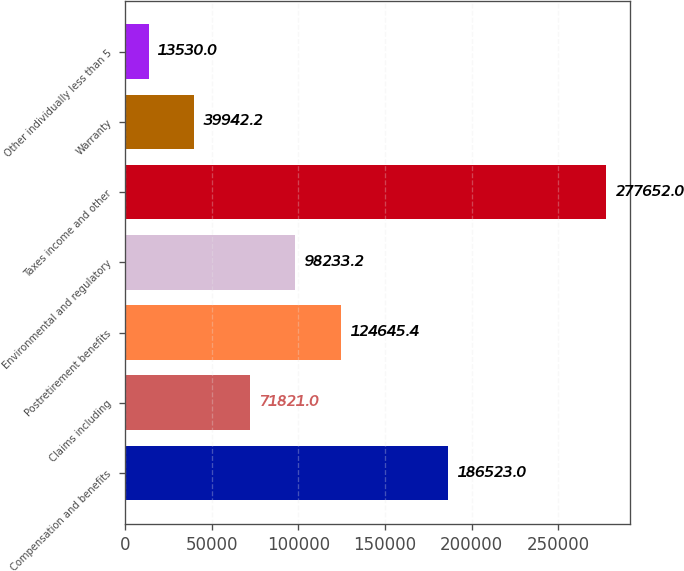Convert chart. <chart><loc_0><loc_0><loc_500><loc_500><bar_chart><fcel>Compensation and benefits<fcel>Claims including<fcel>Postretirement benefits<fcel>Environmental and regulatory<fcel>Taxes income and other<fcel>Warranty<fcel>Other individually less than 5<nl><fcel>186523<fcel>71821<fcel>124645<fcel>98233.2<fcel>277652<fcel>39942.2<fcel>13530<nl></chart> 